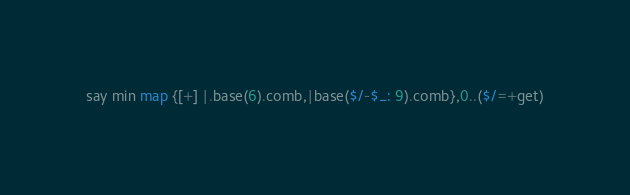Convert code to text. <code><loc_0><loc_0><loc_500><loc_500><_Perl_>say min map {[+] |.base(6).comb,|base($/-$_: 9).comb},0..($/=+get)</code> 